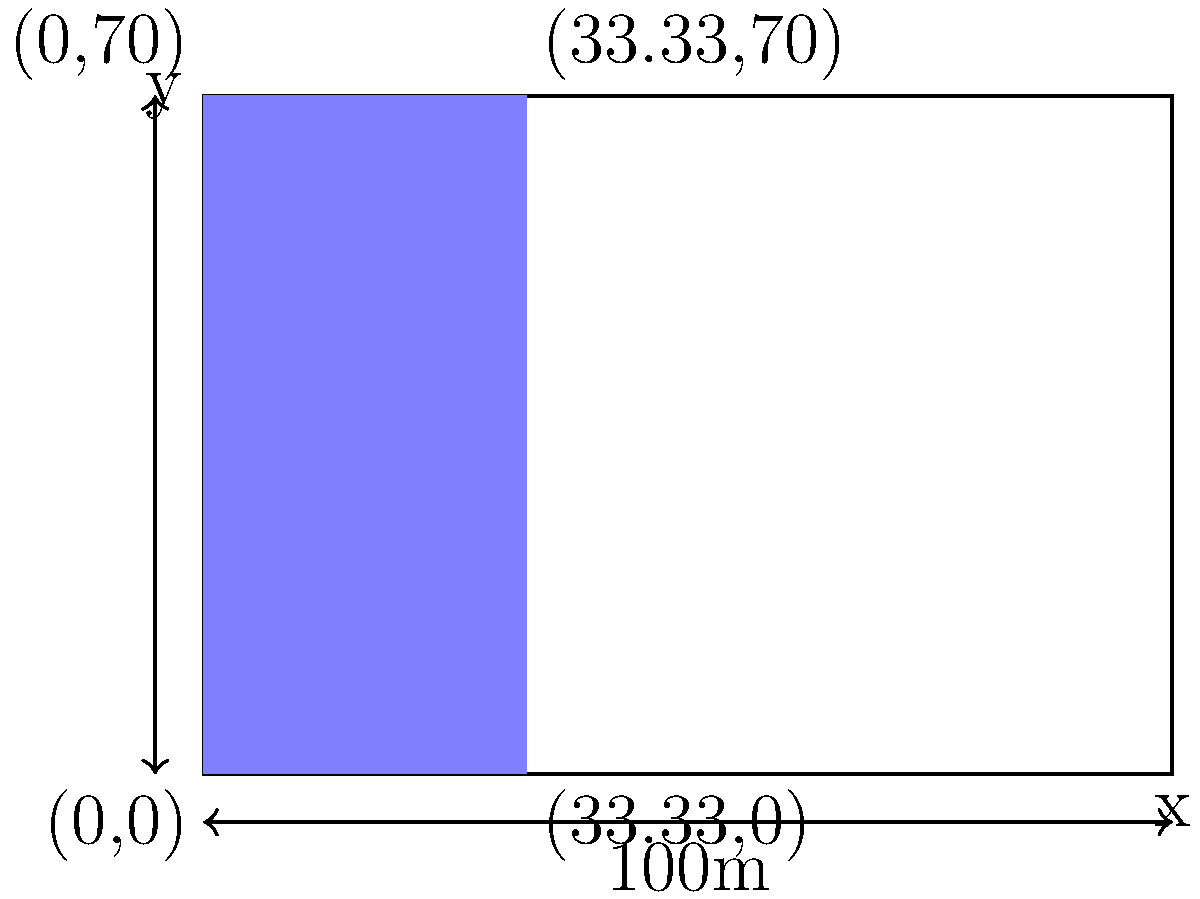In a standard football pitch represented by a coordinate system where the origin (0,0) is at the bottom-left corner, the defensive third extends from the goal line to 33.33 meters into the pitch. If the pitch dimensions are 100 meters long and 70 meters wide, calculate the area of the defensive third using coordinate geometry. Express your answer in square meters. To calculate the area of the defensive third using coordinate geometry, we need to follow these steps:

1) Identify the coordinates of the defensive third:
   Bottom-left: (0,0)
   Bottom-right: (33.33,0)
   Top-right: (33.33,70)
   Top-left: (0,70)

2) The defensive third forms a rectangle. In coordinate geometry, we can calculate the area of a rectangle by finding the difference in x-coordinates (width) and y-coordinates (height) of any two opposite corners.

3) Width of the defensive third:
   $33.33 - 0 = 33.33$ meters

4) Height of the defensive third:
   $70 - 0 = 70$ meters

5) Area of a rectangle is given by the formula:
   $A = width \times height$

6) Substituting our values:
   $A = 33.33 \times 70$

7) Calculate:
   $A = 2333.1$ square meters

Therefore, the area of the defensive third is 2333.1 square meters.
Answer: 2333.1 m² 